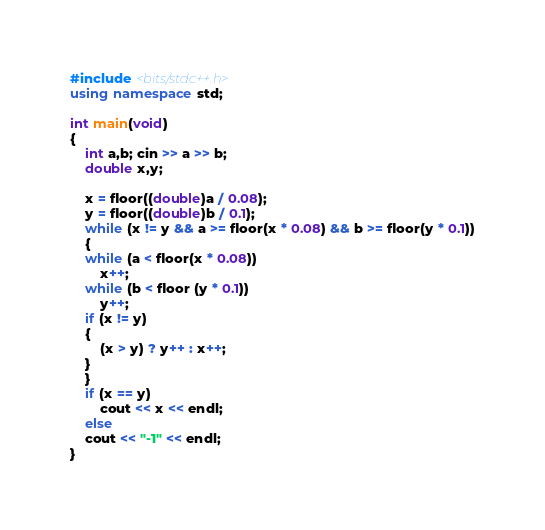Convert code to text. <code><loc_0><loc_0><loc_500><loc_500><_C++_>#include <bits/stdc++.h>
using namespace std;

int main(void)
{
    int a,b; cin >> a >> b;
    double x,y;

    x = floor((double)a / 0.08);
    y = floor((double)b / 0.1);
    while (x != y && a >= floor(x * 0.08) && b >= floor(y * 0.1))
    {
	while (a < floor(x * 0.08))
	    x++;
	while (b < floor (y * 0.1))
	    y++;
	if (x != y)
	{
	    (x > y) ? y++ : x++;
	}
    }
    if (x == y)
    	cout << x << endl;
    else
	cout << "-1" << endl;
}
</code> 